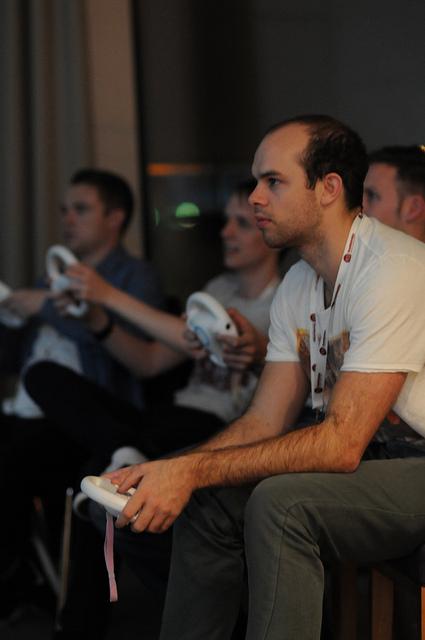What game system is he playing?
Concise answer only. Wii. Is this man trying to be young again?
Keep it brief. No. Which person has a red bracelet on?
Keep it brief. No one. What color is  his shirt?
Short answer required. White. What color shirt is the man wearing?
Answer briefly. White. What type of chair is this known as?
Short answer required. Couch. What is this person doing?
Give a very brief answer. Playing wii. How many people are holding controllers?
Give a very brief answer. 4. What hand is the person holding on the top?
Give a very brief answer. Right. Is he inside?
Write a very short answer. Yes. What does the man have his attention on?
Give a very brief answer. Video game. 